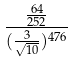<formula> <loc_0><loc_0><loc_500><loc_500>\frac { \frac { 6 4 } { 2 5 2 } } { ( \frac { 3 } { \sqrt { 1 0 } } ) ^ { 4 7 6 } }</formula> 